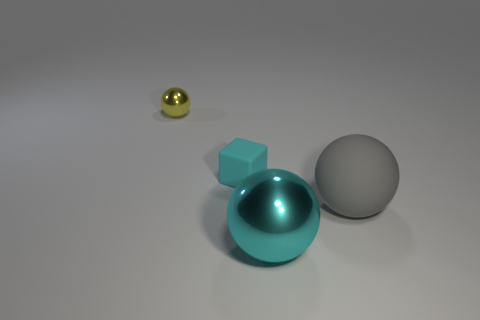Subtract all brown spheres. Subtract all purple cylinders. How many spheres are left? 3 Subtract all brown cylinders. How many blue balls are left? 0 Add 4 objects. How many tiny yellows exist? 0 Subtract all large yellow metal objects. Subtract all tiny cyan cubes. How many objects are left? 3 Add 3 tiny yellow spheres. How many tiny yellow spheres are left? 4 Add 4 small things. How many small things exist? 6 Add 2 large brown shiny blocks. How many objects exist? 6 Subtract all gray balls. How many balls are left? 2 Subtract all big balls. How many balls are left? 1 Subtract 0 green cylinders. How many objects are left? 4 